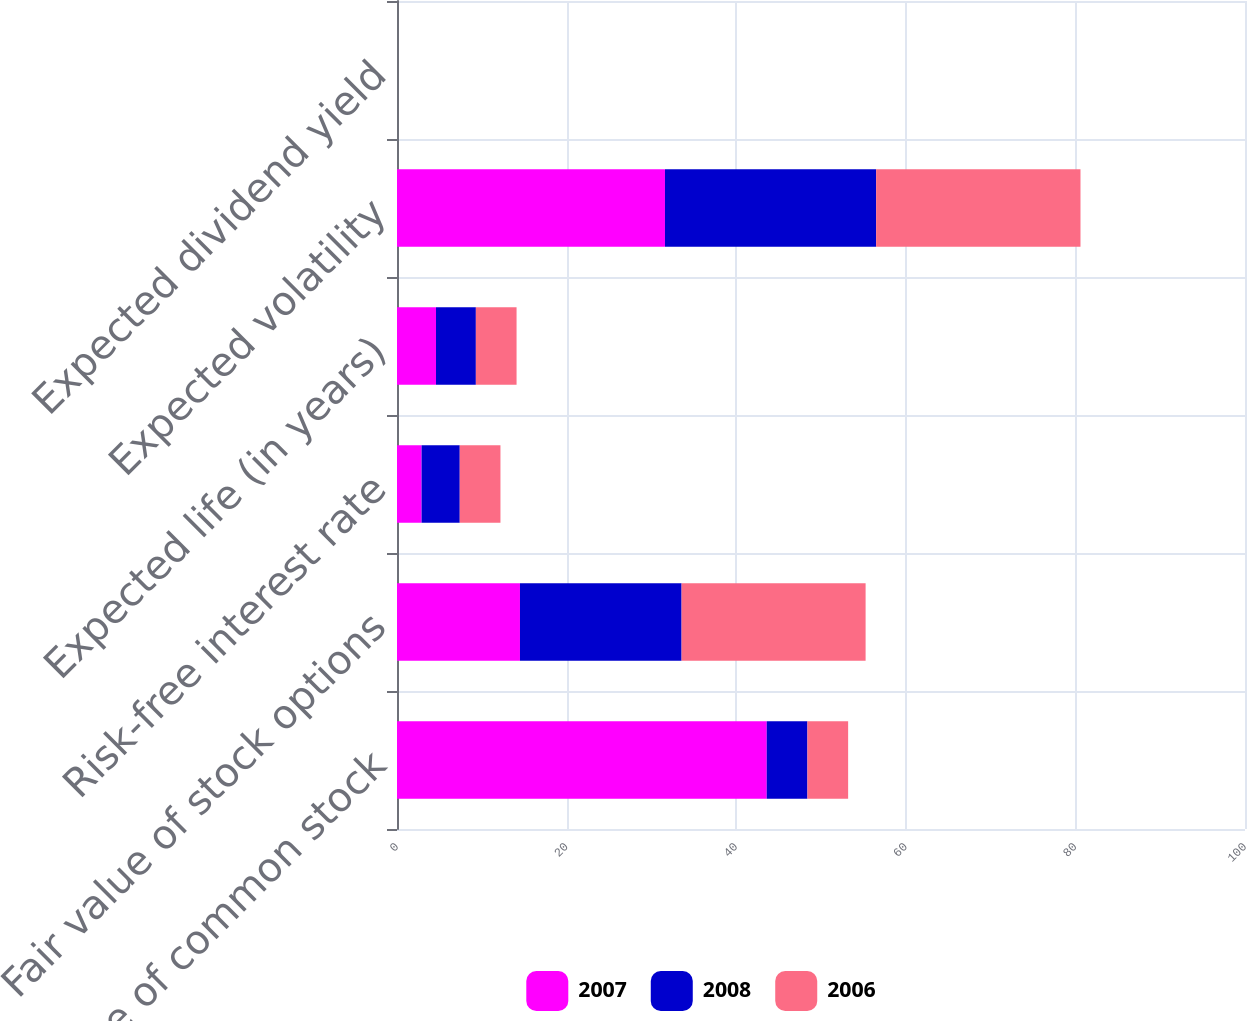<chart> <loc_0><loc_0><loc_500><loc_500><stacked_bar_chart><ecel><fcel>Fair value of common stock<fcel>Fair value of stock options<fcel>Risk-free interest rate<fcel>Expected life (in years)<fcel>Expected volatility<fcel>Expected dividend yield<nl><fcel>2007<fcel>43.6<fcel>14.5<fcel>2.9<fcel>4.6<fcel>31.6<fcel>0<nl><fcel>2008<fcel>4.8<fcel>19.06<fcel>4.5<fcel>4.7<fcel>24.9<fcel>0<nl><fcel>2006<fcel>4.8<fcel>21.7<fcel>4.8<fcel>4.8<fcel>24.1<fcel>0<nl></chart> 